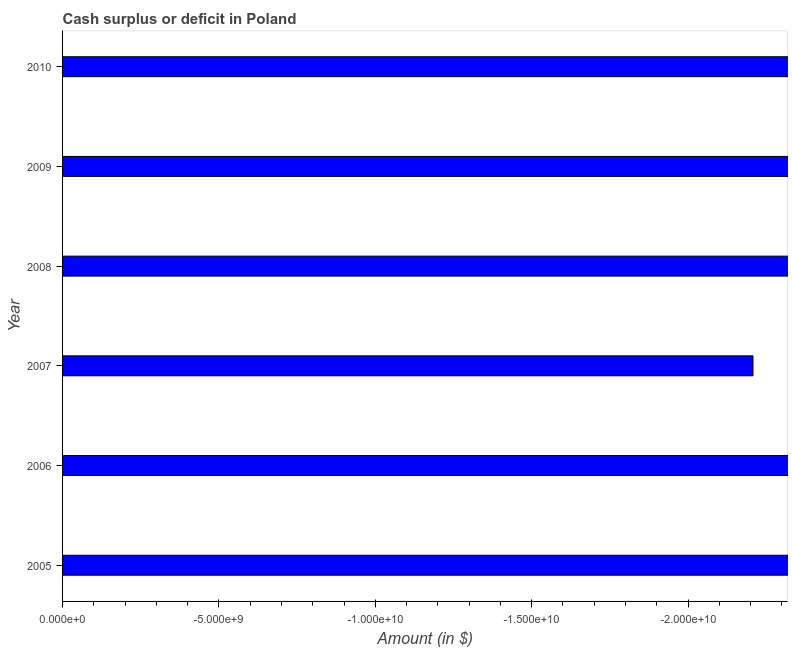Does the graph contain grids?
Your answer should be very brief. No. What is the title of the graph?
Offer a terse response. Cash surplus or deficit in Poland. What is the label or title of the X-axis?
Give a very brief answer. Amount (in $). What is the label or title of the Y-axis?
Keep it short and to the point. Year. What is the cash surplus or deficit in 2008?
Provide a succinct answer. 0. Across all years, what is the minimum cash surplus or deficit?
Provide a short and direct response. 0. What is the sum of the cash surplus or deficit?
Your answer should be very brief. 0. Are all the bars in the graph horizontal?
Make the answer very short. Yes. How many years are there in the graph?
Your response must be concise. 6. What is the difference between two consecutive major ticks on the X-axis?
Make the answer very short. 5.00e+09. What is the Amount (in $) of 2007?
Provide a short and direct response. 0. What is the Amount (in $) in 2009?
Ensure brevity in your answer.  0. 